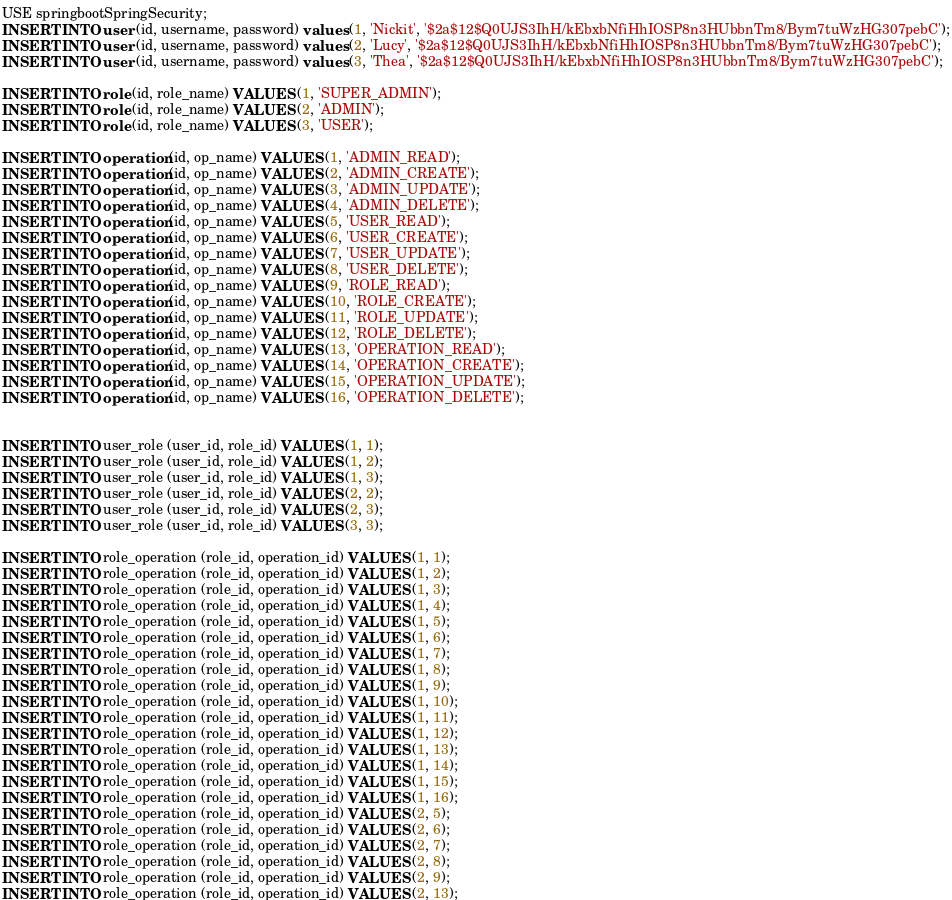<code> <loc_0><loc_0><loc_500><loc_500><_SQL_>USE springbootSpringSecurity;
INSERT INTO user (id, username, password) values (1, 'Nickit', '$2a$12$Q0UJS3IhH/kEbxbNfiHhIOSP8n3HUbbnTm8/Bym7tuWzHG307pebC');
INSERT INTO user (id, username, password) values (2, 'Lucy', '$2a$12$Q0UJS3IhH/kEbxbNfiHhIOSP8n3HUbbnTm8/Bym7tuWzHG307pebC');
INSERT INTO user (id, username, password) values (3, 'Thea', '$2a$12$Q0UJS3IhH/kEbxbNfiHhIOSP8n3HUbbnTm8/Bym7tuWzHG307pebC');

INSERT INTO role (id, role_name) VALUES (1, 'SUPER_ADMIN');
INSERT INTO role (id, role_name) VALUES (2, 'ADMIN');
INSERT INTO role (id, role_name) VALUES (3, 'USER');

INSERT INTO operation (id, op_name) VALUES (1, 'ADMIN_READ');
INSERT INTO operation (id, op_name) VALUES (2, 'ADMIN_CREATE');
INSERT INTO operation (id, op_name) VALUES (3, 'ADMIN_UPDATE');
INSERT INTO operation (id, op_name) VALUES (4, 'ADMIN_DELETE');
INSERT INTO operation (id, op_name) VALUES (5, 'USER_READ');
INSERT INTO operation (id, op_name) VALUES (6, 'USER_CREATE');
INSERT INTO operation (id, op_name) VALUES (7, 'USER_UPDATE');
INSERT INTO operation (id, op_name) VALUES (8, 'USER_DELETE');
INSERT INTO operation (id, op_name) VALUES (9, 'ROLE_READ');
INSERT INTO operation (id, op_name) VALUES (10, 'ROLE_CREATE');
INSERT INTO operation (id, op_name) VALUES (11, 'ROLE_UPDATE');
INSERT INTO operation (id, op_name) VALUES (12, 'ROLE_DELETE');
INSERT INTO operation (id, op_name) VALUES (13, 'OPERATION_READ');
INSERT INTO operation (id, op_name) VALUES (14, 'OPERATION_CREATE');
INSERT INTO operation (id, op_name) VALUES (15, 'OPERATION_UPDATE');
INSERT INTO operation (id, op_name) VALUES (16, 'OPERATION_DELETE');


INSERT INTO user_role (user_id, role_id) VALUES (1, 1);
INSERT INTO user_role (user_id, role_id) VALUES (1, 2);
INSERT INTO user_role (user_id, role_id) VALUES (1, 3);
INSERT INTO user_role (user_id, role_id) VALUES (2, 2);
INSERT INTO user_role (user_id, role_id) VALUES (2, 3);
INSERT INTO user_role (user_id, role_id) VALUES (3, 3);

INSERT INTO role_operation (role_id, operation_id) VALUES (1, 1);
INSERT INTO role_operation (role_id, operation_id) VALUES (1, 2);
INSERT INTO role_operation (role_id, operation_id) VALUES (1, 3);
INSERT INTO role_operation (role_id, operation_id) VALUES (1, 4);
INSERT INTO role_operation (role_id, operation_id) VALUES (1, 5);
INSERT INTO role_operation (role_id, operation_id) VALUES (1, 6);
INSERT INTO role_operation (role_id, operation_id) VALUES (1, 7);
INSERT INTO role_operation (role_id, operation_id) VALUES (1, 8);
INSERT INTO role_operation (role_id, operation_id) VALUES (1, 9);
INSERT INTO role_operation (role_id, operation_id) VALUES (1, 10);
INSERT INTO role_operation (role_id, operation_id) VALUES (1, 11);
INSERT INTO role_operation (role_id, operation_id) VALUES (1, 12);
INSERT INTO role_operation (role_id, operation_id) VALUES (1, 13);
INSERT INTO role_operation (role_id, operation_id) VALUES (1, 14);
INSERT INTO role_operation (role_id, operation_id) VALUES (1, 15);
INSERT INTO role_operation (role_id, operation_id) VALUES (1, 16);
INSERT INTO role_operation (role_id, operation_id) VALUES (2, 5);
INSERT INTO role_operation (role_id, operation_id) VALUES (2, 6);
INSERT INTO role_operation (role_id, operation_id) VALUES (2, 7);
INSERT INTO role_operation (role_id, operation_id) VALUES (2, 8);
INSERT INTO role_operation (role_id, operation_id) VALUES (2, 9);
INSERT INTO role_operation (role_id, operation_id) VALUES (2, 13);</code> 